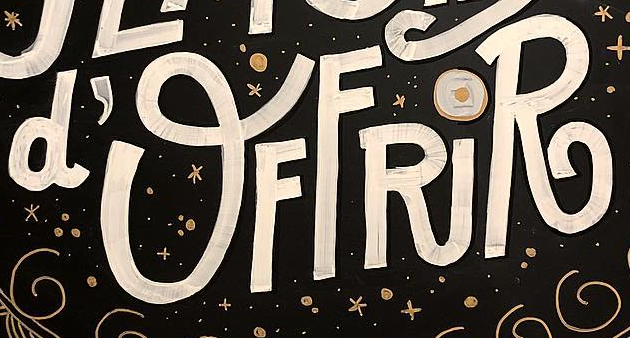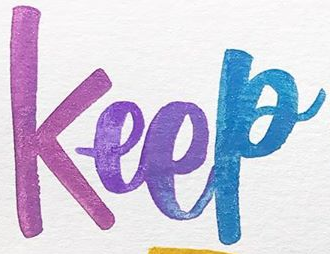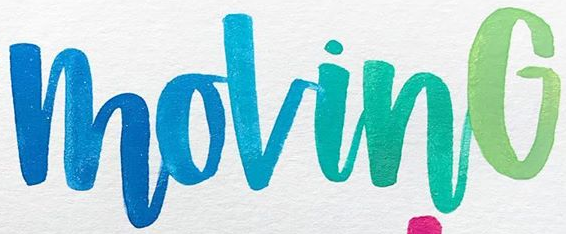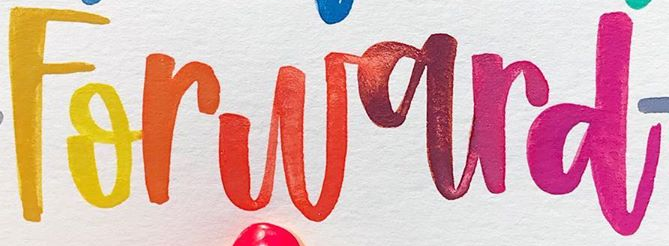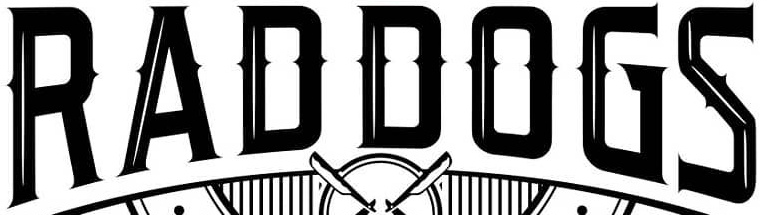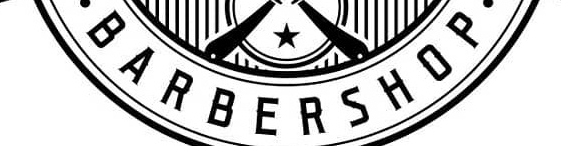Transcribe the words shown in these images in order, separated by a semicolon. d'OFFRiR; Keep; MovinG; Forward; RADDOGS; BARBERSHOP 